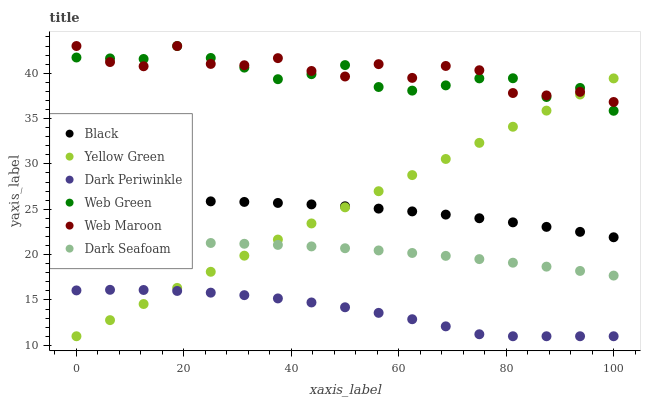Does Dark Periwinkle have the minimum area under the curve?
Answer yes or no. Yes. Does Web Maroon have the maximum area under the curve?
Answer yes or no. Yes. Does Web Green have the minimum area under the curve?
Answer yes or no. No. Does Web Green have the maximum area under the curve?
Answer yes or no. No. Is Yellow Green the smoothest?
Answer yes or no. Yes. Is Web Maroon the roughest?
Answer yes or no. Yes. Is Web Green the smoothest?
Answer yes or no. No. Is Web Green the roughest?
Answer yes or no. No. Does Yellow Green have the lowest value?
Answer yes or no. Yes. Does Web Green have the lowest value?
Answer yes or no. No. Does Web Green have the highest value?
Answer yes or no. Yes. Does Dark Seafoam have the highest value?
Answer yes or no. No. Is Dark Periwinkle less than Web Maroon?
Answer yes or no. Yes. Is Web Green greater than Black?
Answer yes or no. Yes. Does Dark Periwinkle intersect Yellow Green?
Answer yes or no. Yes. Is Dark Periwinkle less than Yellow Green?
Answer yes or no. No. Is Dark Periwinkle greater than Yellow Green?
Answer yes or no. No. Does Dark Periwinkle intersect Web Maroon?
Answer yes or no. No. 